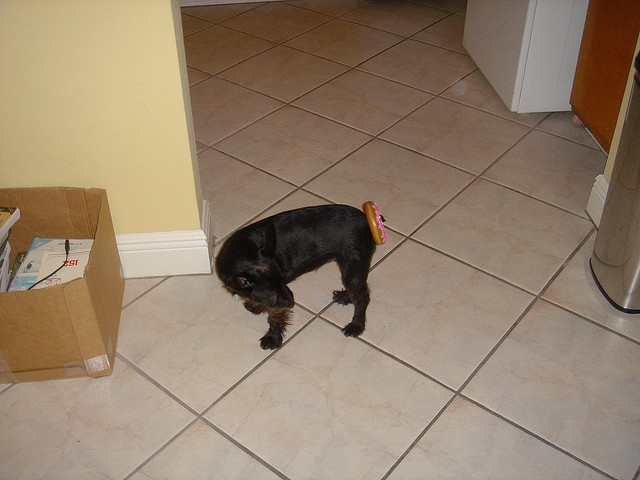Describe the objects in this image and their specific colors. I can see dog in tan, black, maroon, gray, and darkgray tones, refrigerator in tan and gray tones, book in tan, darkgray, and gray tones, donut in tan, brown, violet, and maroon tones, and book in tan, darkgray, olive, gray, and maroon tones in this image. 